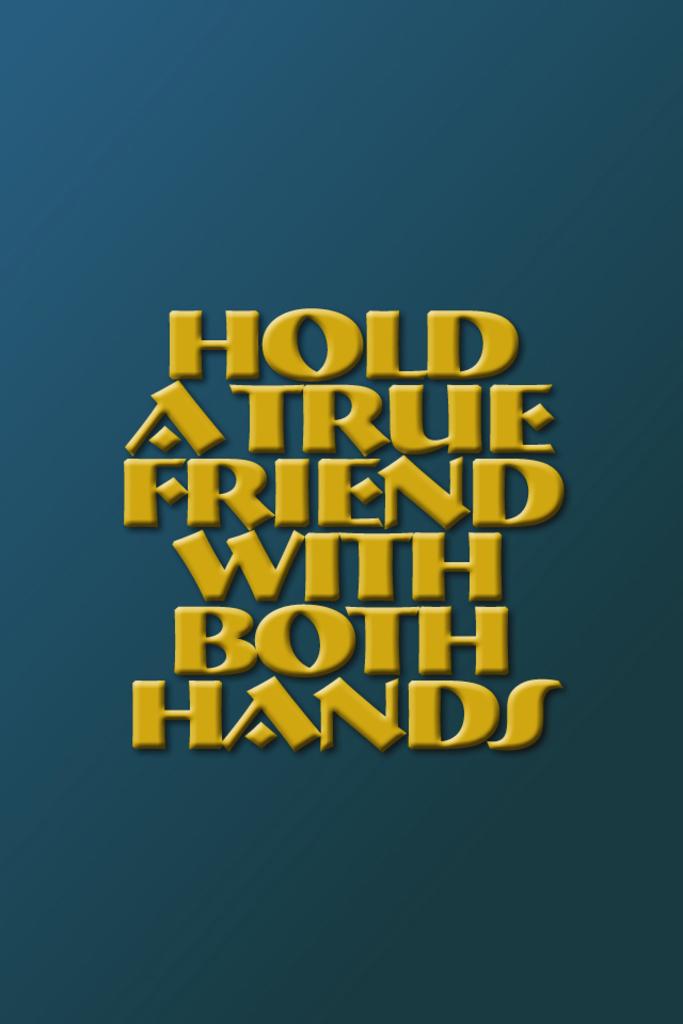What can be held with both hands?
Provide a short and direct response. A true friend. What should you do with a true friend?
Ensure brevity in your answer.  Hold with both hands. 